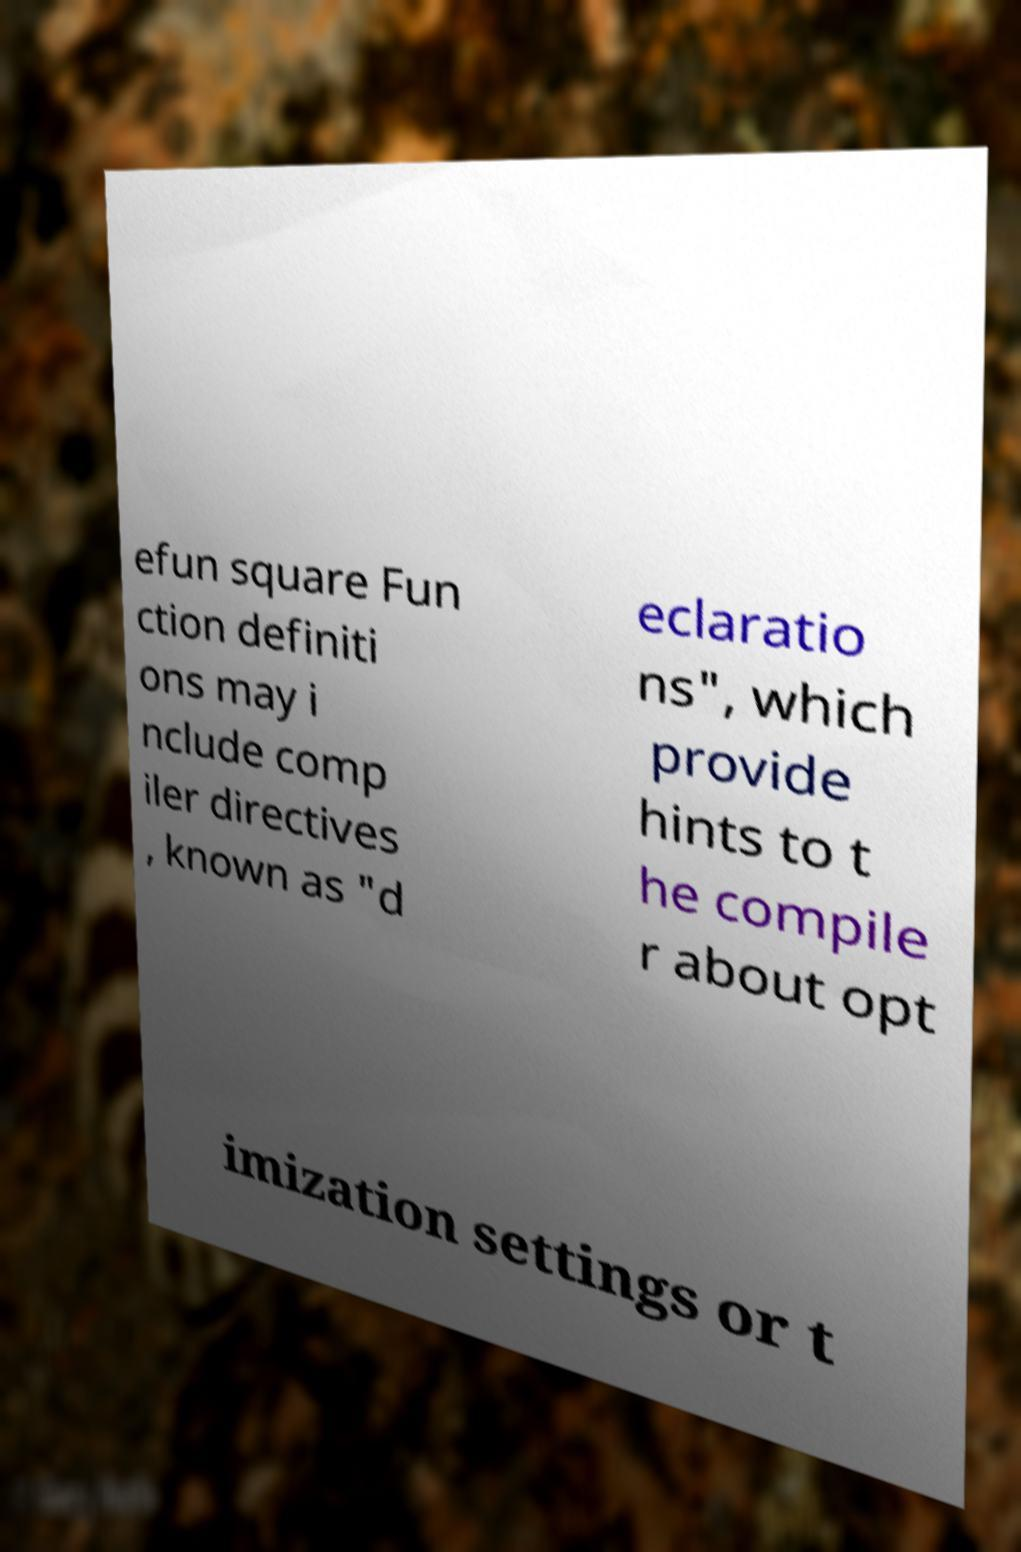Please identify and transcribe the text found in this image. efun square Fun ction definiti ons may i nclude comp iler directives , known as "d eclaratio ns", which provide hints to t he compile r about opt imization settings or t 